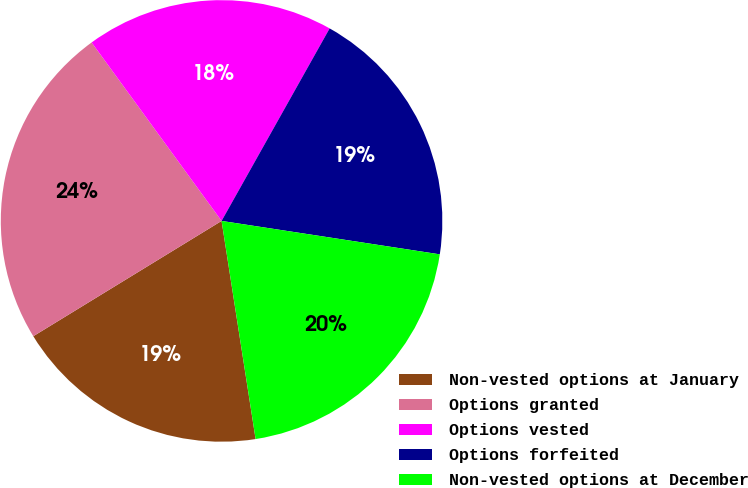Convert chart to OTSL. <chart><loc_0><loc_0><loc_500><loc_500><pie_chart><fcel>Non-vested options at January<fcel>Options granted<fcel>Options vested<fcel>Options forfeited<fcel>Non-vested options at December<nl><fcel>18.72%<fcel>23.73%<fcel>18.16%<fcel>19.28%<fcel>20.12%<nl></chart> 